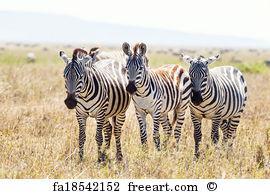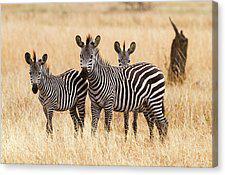The first image is the image on the left, the second image is the image on the right. Assess this claim about the two images: "Each image contains exactly three zebras, and no zebras are standing with their rears facing the camera.". Correct or not? Answer yes or no. Yes. 